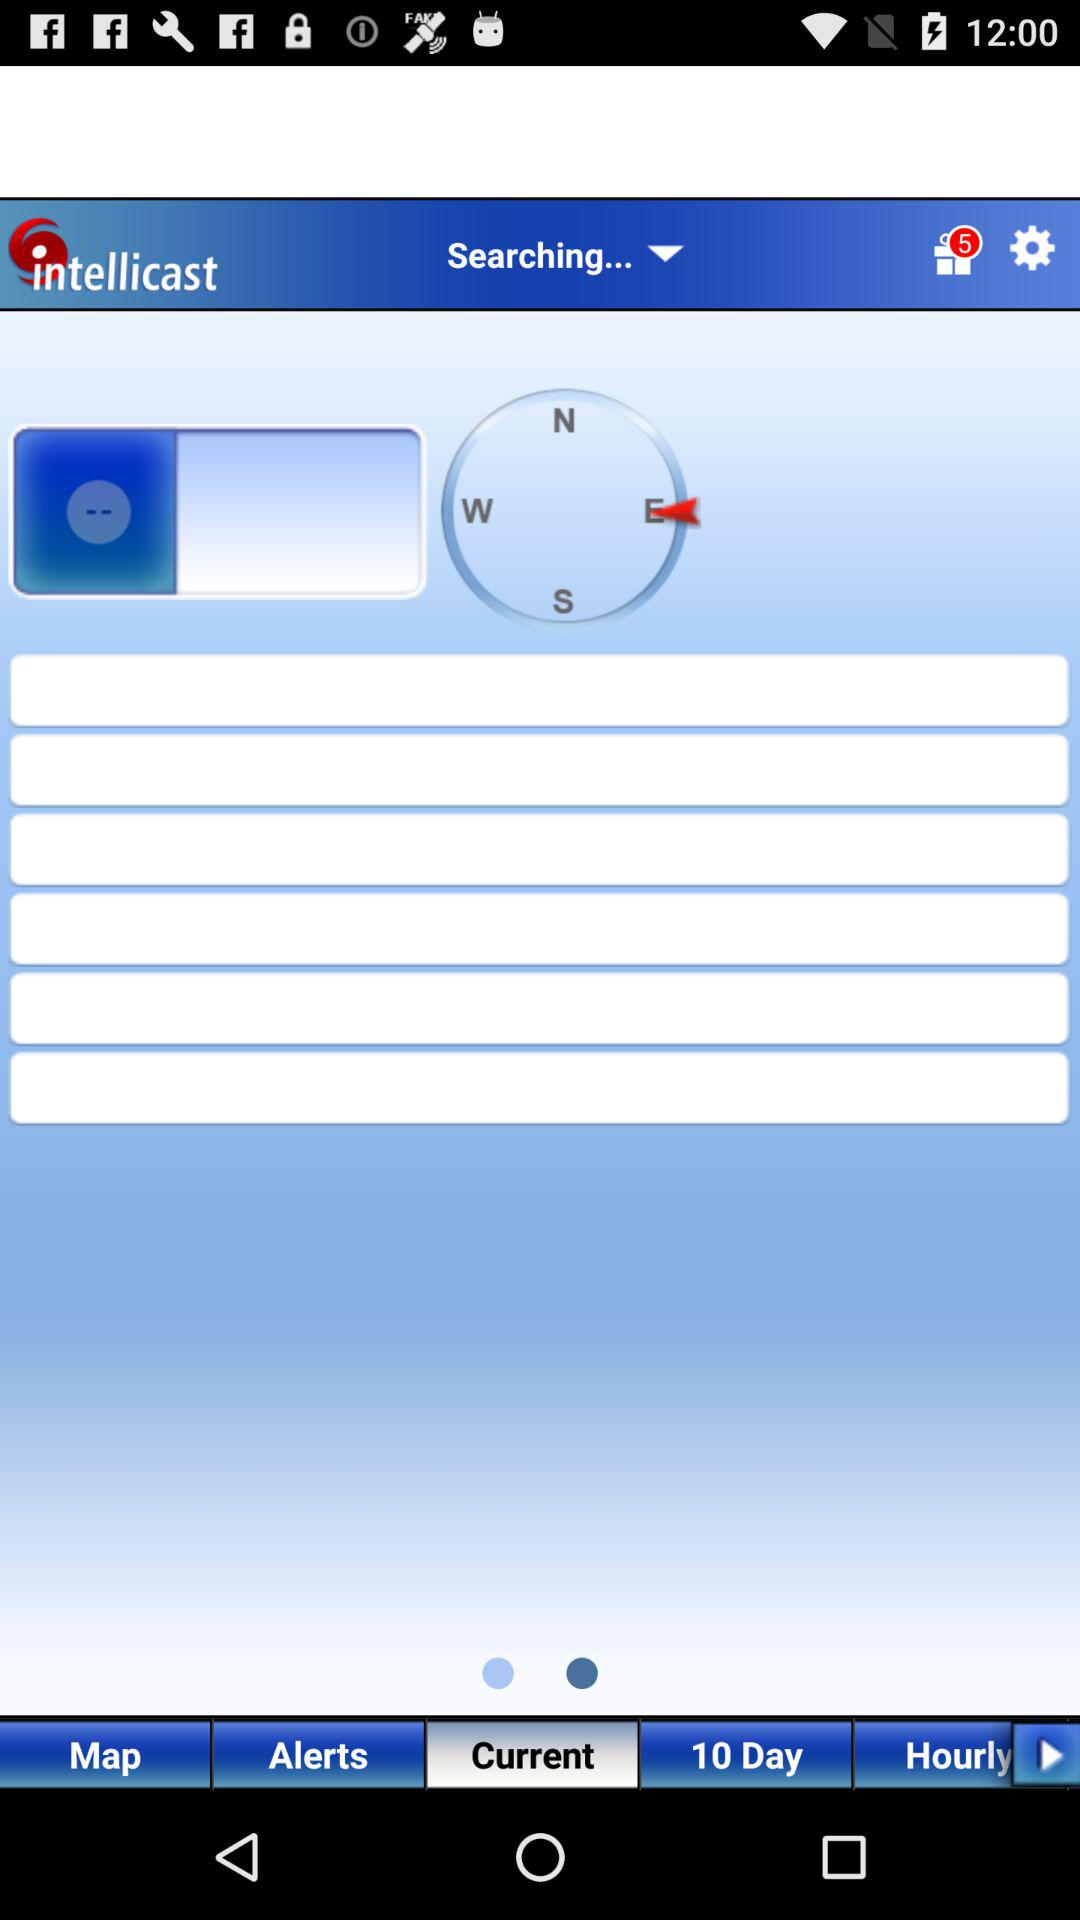Which tab is selected? The selected tab is "Current". 